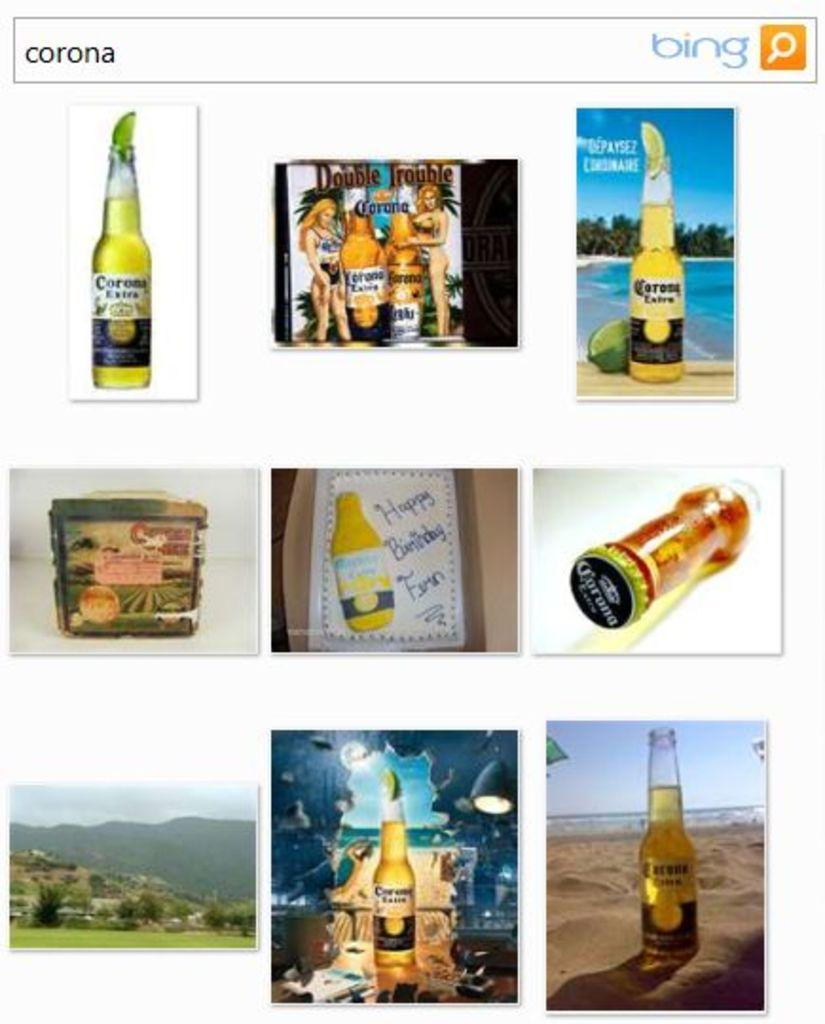<image>
Give a short and clear explanation of the subsequent image. Search screen for corona that shows many photos of Corona. 